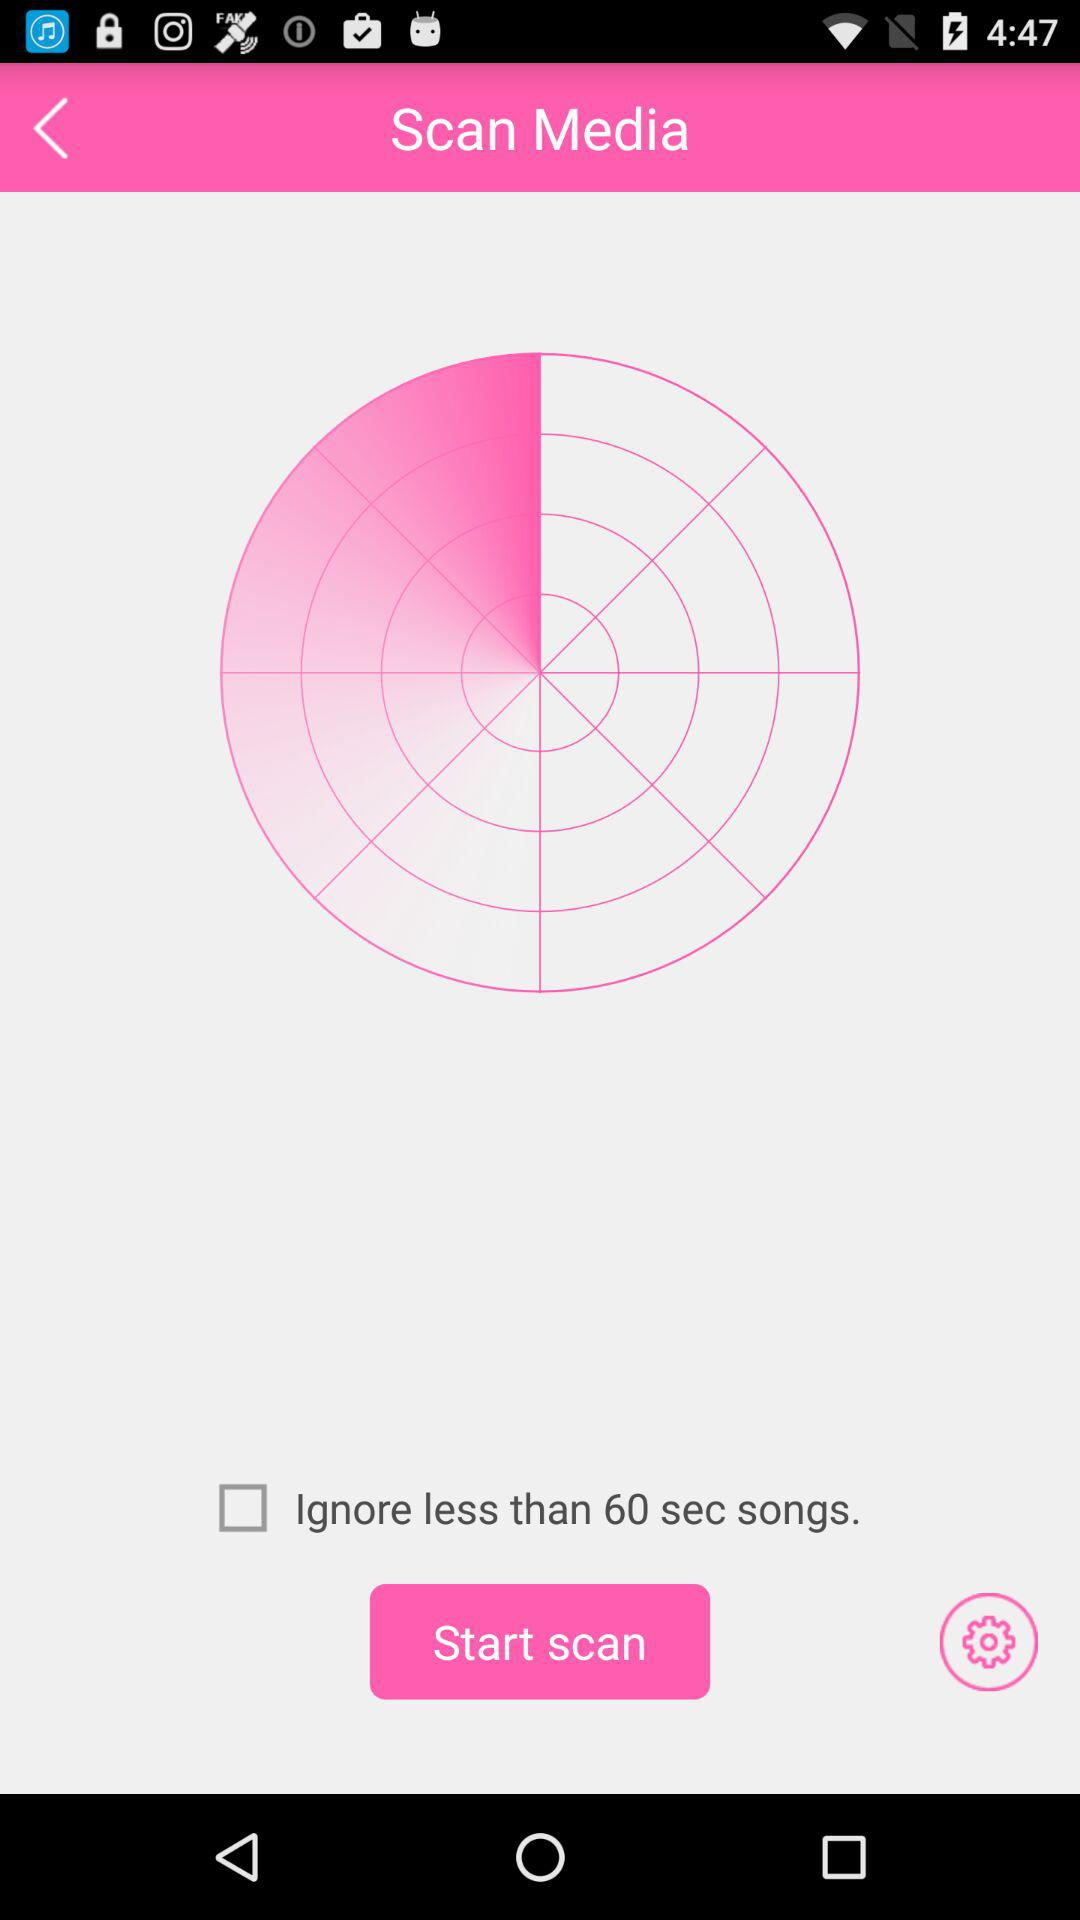What is the name of application?
When the provided information is insufficient, respond with <no answer>. <no answer> 